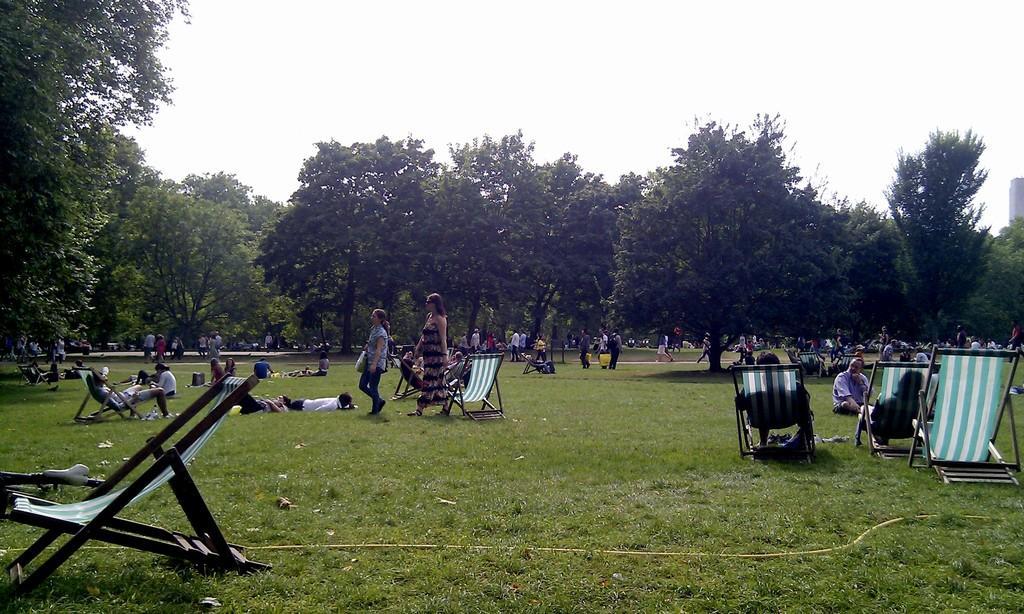Can you describe this image briefly? In this picture we can see a group of people sitting on the chairs, some people are standing and some people are lying on the grass path. Behind the people there are trees and a sky. 